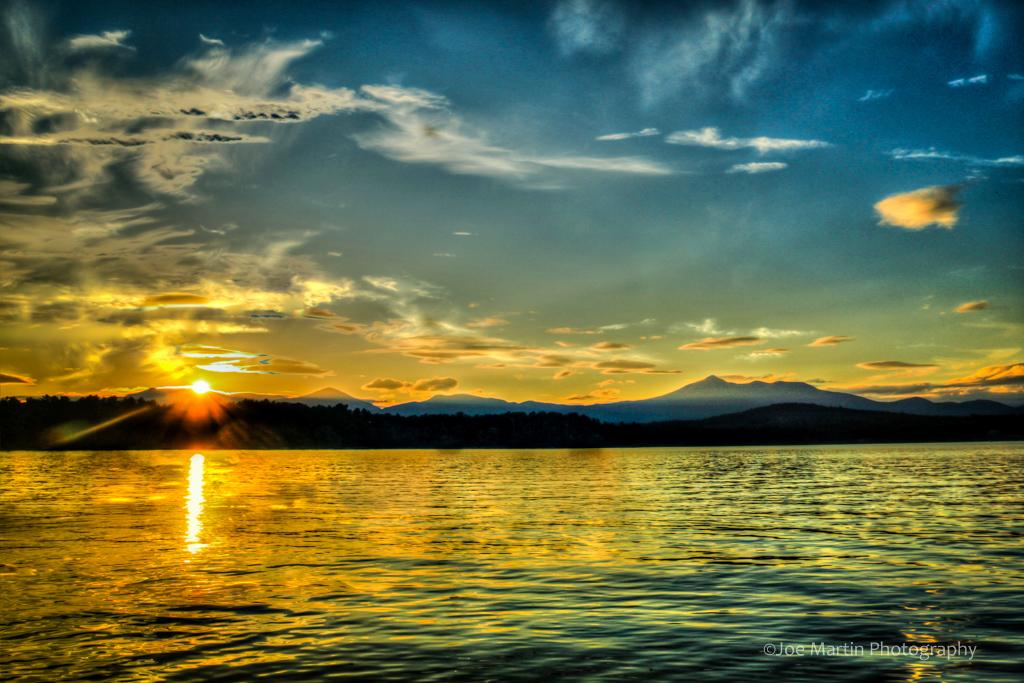What can be found in the bottom right corner of the image? There is a watermark in the bottom right corner of the image. What is present at the bottom of the image? There is water at the bottom of the image. What can be seen in the background of the image? There are mountains in the background of the image. What is visible in the sky in the image? There are clouds and the sun visible in the sky. What type of prose is being recited by the mountains in the image? There is no indication in the image that the mountains are reciting any prose. Can you tell me how the face of the sun feels about the clouds in the image? The image does not depict the sun having a face or emotions, so it is not possible to determine how the sun feels about the clouds. 